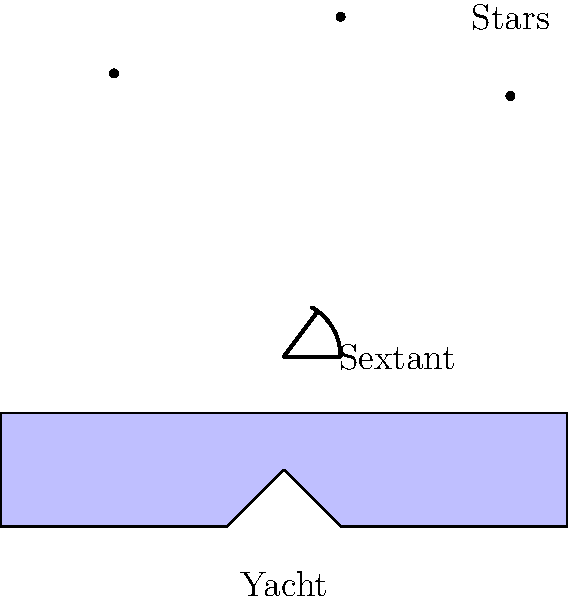While cruising on your luxury yacht in the Mediterranean, you decide to practice celestial navigation using a sextant. If the observed altitude of Polaris is $41°30'$ and the sextant's index error is $-2'$, what is the yacht's approximate latitude? To determine the yacht's approximate latitude using Polaris, follow these steps:

1. Correct the observed altitude for the sextant's index error:
   Observed altitude: $41°30'$
   Index error: $-2'$
   Corrected altitude = $41°30' - (-2') = 41°32'$

2. The altitude of Polaris closely approximates the observer's latitude. However, a small correction is typically applied for precise measurements. For this approximation, we'll assume the corrected altitude is equal to the latitude.

3. Convert the corrected altitude to decimal degrees:
   $41°32' = 41 + (32/60) = 41.5333°$

4. Round to the nearest degree for an approximate latitude:
   $41.5333° ≈ 42°N$

Therefore, the yacht's approximate latitude is $42°N$ in the Mediterranean Sea.
Answer: $42°N$ 